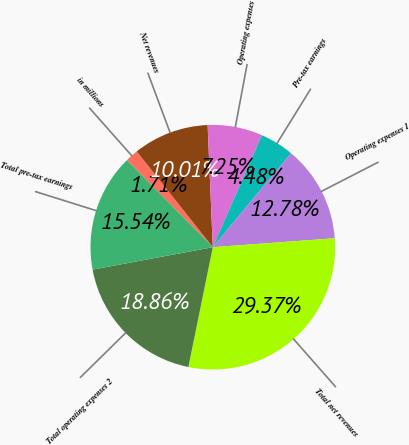Convert chart to OTSL. <chart><loc_0><loc_0><loc_500><loc_500><pie_chart><fcel>in millions<fcel>Net revenues<fcel>Operating expenses<fcel>Pre-tax earnings<fcel>Operating expenses 1<fcel>Total net revenues<fcel>Total operating expenses 2<fcel>Total pre-tax earnings<nl><fcel>1.71%<fcel>10.01%<fcel>7.25%<fcel>4.48%<fcel>12.78%<fcel>29.37%<fcel>18.86%<fcel>15.54%<nl></chart> 